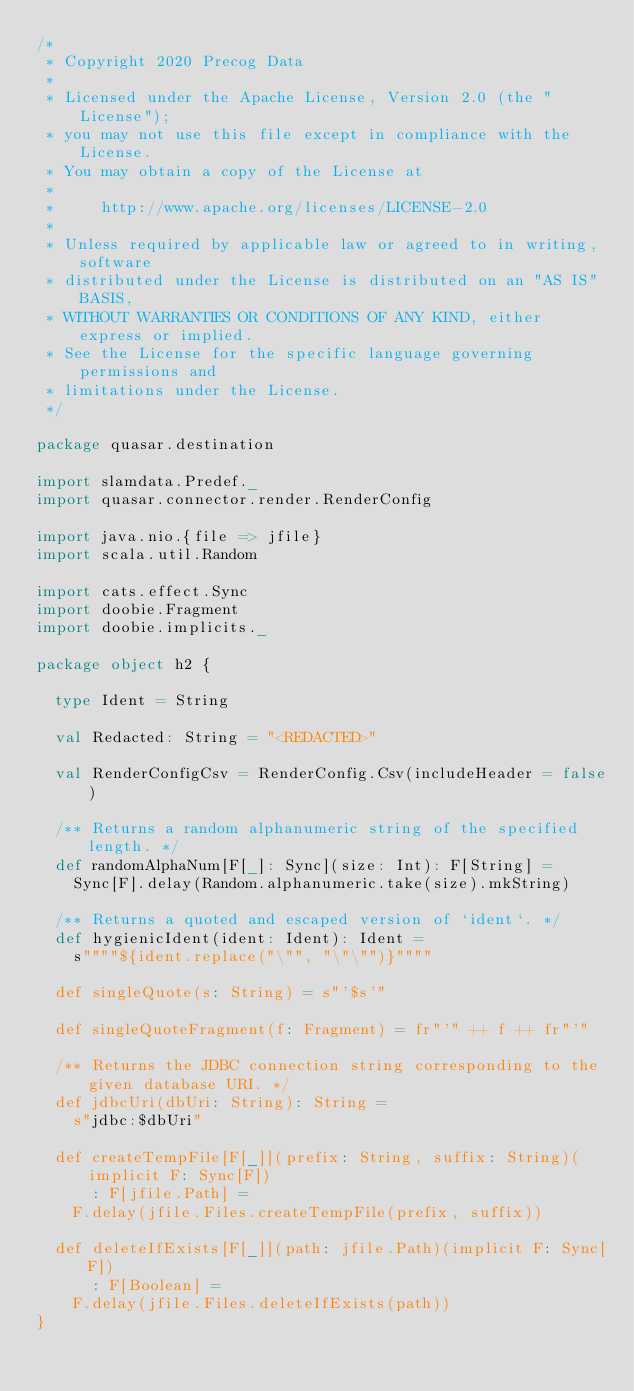<code> <loc_0><loc_0><loc_500><loc_500><_Scala_>/*
 * Copyright 2020 Precog Data
 *
 * Licensed under the Apache License, Version 2.0 (the "License");
 * you may not use this file except in compliance with the License.
 * You may obtain a copy of the License at
 *
 *     http://www.apache.org/licenses/LICENSE-2.0
 *
 * Unless required by applicable law or agreed to in writing, software
 * distributed under the License is distributed on an "AS IS" BASIS,
 * WITHOUT WARRANTIES OR CONDITIONS OF ANY KIND, either express or implied.
 * See the License for the specific language governing permissions and
 * limitations under the License.
 */

package quasar.destination

import slamdata.Predef._
import quasar.connector.render.RenderConfig

import java.nio.{file => jfile}
import scala.util.Random

import cats.effect.Sync
import doobie.Fragment
import doobie.implicits._

package object h2 {

  type Ident = String

  val Redacted: String = "<REDACTED>"

  val RenderConfigCsv = RenderConfig.Csv(includeHeader = false)

  /** Returns a random alphanumeric string of the specified length. */
  def randomAlphaNum[F[_]: Sync](size: Int): F[String] =
    Sync[F].delay(Random.alphanumeric.take(size).mkString)

  /** Returns a quoted and escaped version of `ident`. */
  def hygienicIdent(ident: Ident): Ident =
    s""""${ident.replace("\"", "\"\"")}""""

  def singleQuote(s: String) = s"'$s'"

  def singleQuoteFragment(f: Fragment) = fr"'" ++ f ++ fr"'"

  /** Returns the JDBC connection string corresponding to the given database URI. */
  def jdbcUri(dbUri: String): String =
    s"jdbc:$dbUri"

  def createTempFile[F[_]](prefix: String, suffix: String)(implicit F: Sync[F])
      : F[jfile.Path] =
    F.delay(jfile.Files.createTempFile(prefix, suffix))

  def deleteIfExists[F[_]](path: jfile.Path)(implicit F: Sync[F])
      : F[Boolean] =
    F.delay(jfile.Files.deleteIfExists(path))
}
</code> 